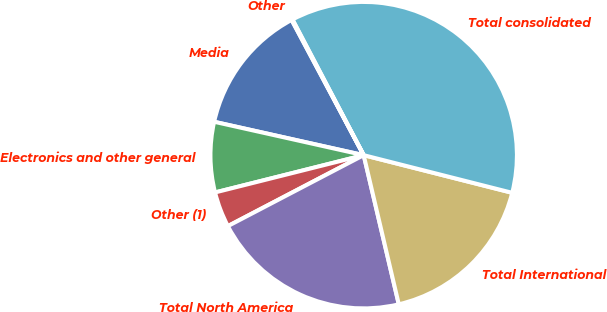<chart> <loc_0><loc_0><loc_500><loc_500><pie_chart><fcel>Media<fcel>Electronics and other general<fcel>Other (1)<fcel>Total North America<fcel>Total International<fcel>Total consolidated<fcel>Other<nl><fcel>13.71%<fcel>7.41%<fcel>3.75%<fcel>21.02%<fcel>17.37%<fcel>36.65%<fcel>0.1%<nl></chart> 